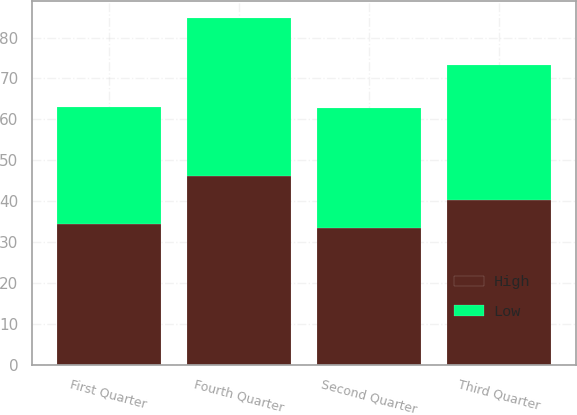Convert chart. <chart><loc_0><loc_0><loc_500><loc_500><stacked_bar_chart><ecel><fcel>First Quarter<fcel>Second Quarter<fcel>Third Quarter<fcel>Fourth Quarter<nl><fcel>High<fcel>34.5<fcel>33.49<fcel>40.29<fcel>46.06<nl><fcel>Low<fcel>28.47<fcel>29.25<fcel>33.1<fcel>38.72<nl></chart> 